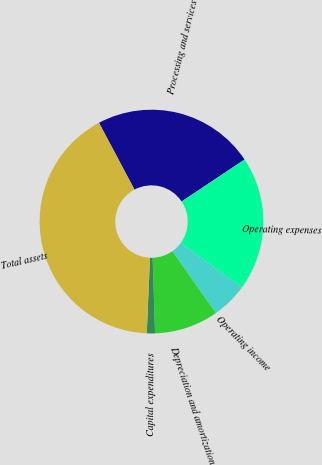<chart> <loc_0><loc_0><loc_500><loc_500><pie_chart><fcel>Processing and services<fcel>Operating expenses<fcel>Operating income<fcel>Depreciation and amortization<fcel>Capital expenditures<fcel>Total assets<nl><fcel>23.42%<fcel>19.38%<fcel>5.22%<fcel>9.25%<fcel>1.18%<fcel>41.55%<nl></chart> 